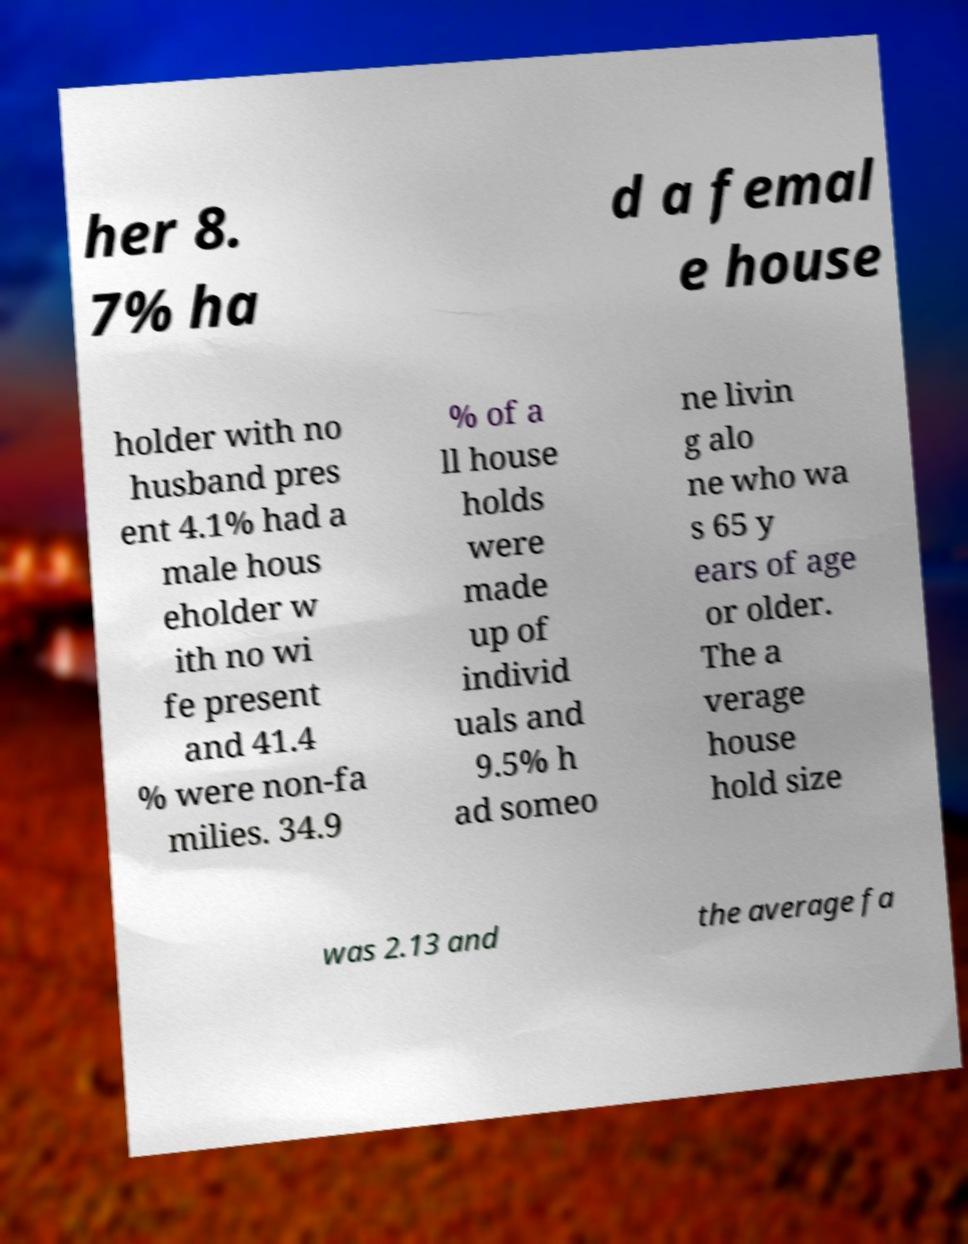Could you assist in decoding the text presented in this image and type it out clearly? her 8. 7% ha d a femal e house holder with no husband pres ent 4.1% had a male hous eholder w ith no wi fe present and 41.4 % were non-fa milies. 34.9 % of a ll house holds were made up of individ uals and 9.5% h ad someo ne livin g alo ne who wa s 65 y ears of age or older. The a verage house hold size was 2.13 and the average fa 